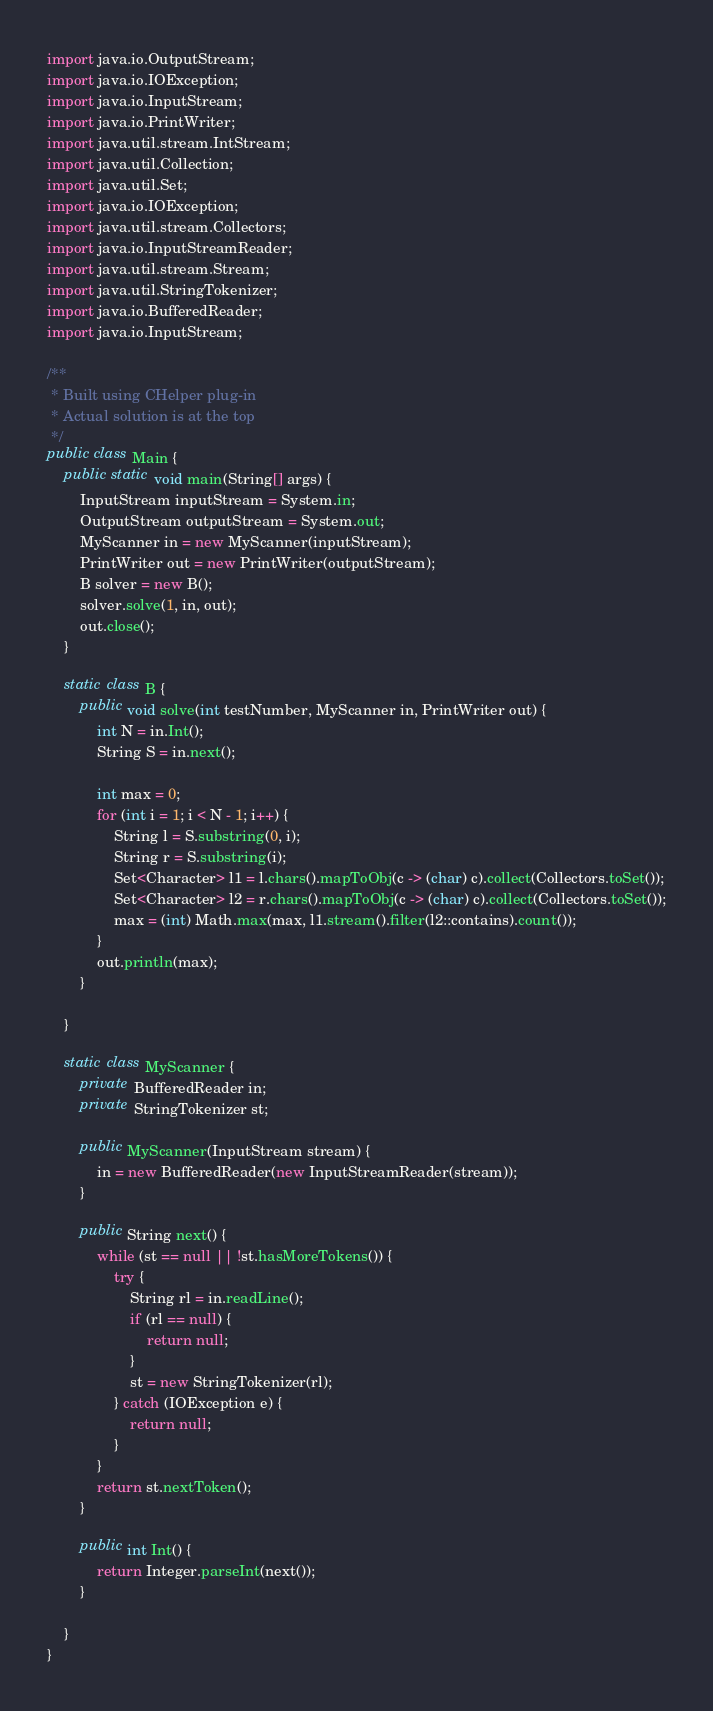Convert code to text. <code><loc_0><loc_0><loc_500><loc_500><_Java_>import java.io.OutputStream;
import java.io.IOException;
import java.io.InputStream;
import java.io.PrintWriter;
import java.util.stream.IntStream;
import java.util.Collection;
import java.util.Set;
import java.io.IOException;
import java.util.stream.Collectors;
import java.io.InputStreamReader;
import java.util.stream.Stream;
import java.util.StringTokenizer;
import java.io.BufferedReader;
import java.io.InputStream;

/**
 * Built using CHelper plug-in
 * Actual solution is at the top
 */
public class Main {
    public static void main(String[] args) {
        InputStream inputStream = System.in;
        OutputStream outputStream = System.out;
        MyScanner in = new MyScanner(inputStream);
        PrintWriter out = new PrintWriter(outputStream);
        B solver = new B();
        solver.solve(1, in, out);
        out.close();
    }

    static class B {
        public void solve(int testNumber, MyScanner in, PrintWriter out) {
            int N = in.Int();
            String S = in.next();

            int max = 0;
            for (int i = 1; i < N - 1; i++) {
                String l = S.substring(0, i);
                String r = S.substring(i);
                Set<Character> l1 = l.chars().mapToObj(c -> (char) c).collect(Collectors.toSet());
                Set<Character> l2 = r.chars().mapToObj(c -> (char) c).collect(Collectors.toSet());
                max = (int) Math.max(max, l1.stream().filter(l2::contains).count());
            }
            out.println(max);
        }

    }

    static class MyScanner {
        private BufferedReader in;
        private StringTokenizer st;

        public MyScanner(InputStream stream) {
            in = new BufferedReader(new InputStreamReader(stream));
        }

        public String next() {
            while (st == null || !st.hasMoreTokens()) {
                try {
                    String rl = in.readLine();
                    if (rl == null) {
                        return null;
                    }
                    st = new StringTokenizer(rl);
                } catch (IOException e) {
                    return null;
                }
            }
            return st.nextToken();
        }

        public int Int() {
            return Integer.parseInt(next());
        }

    }
}

</code> 